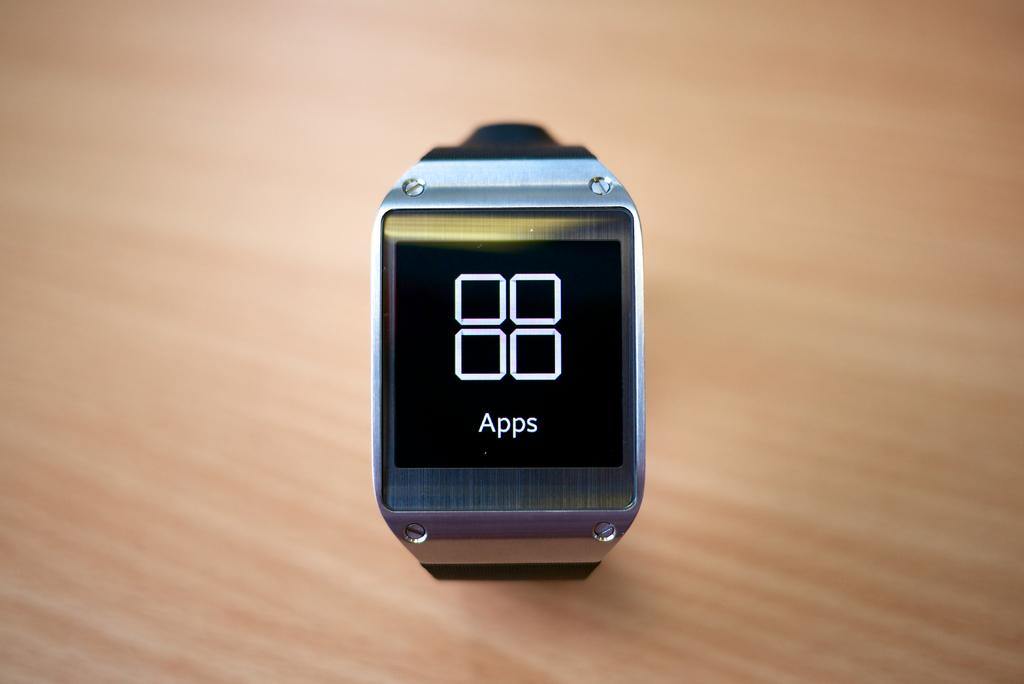Provide a one-sentence caption for the provided image. Smart watch that have apps on the front of it. 